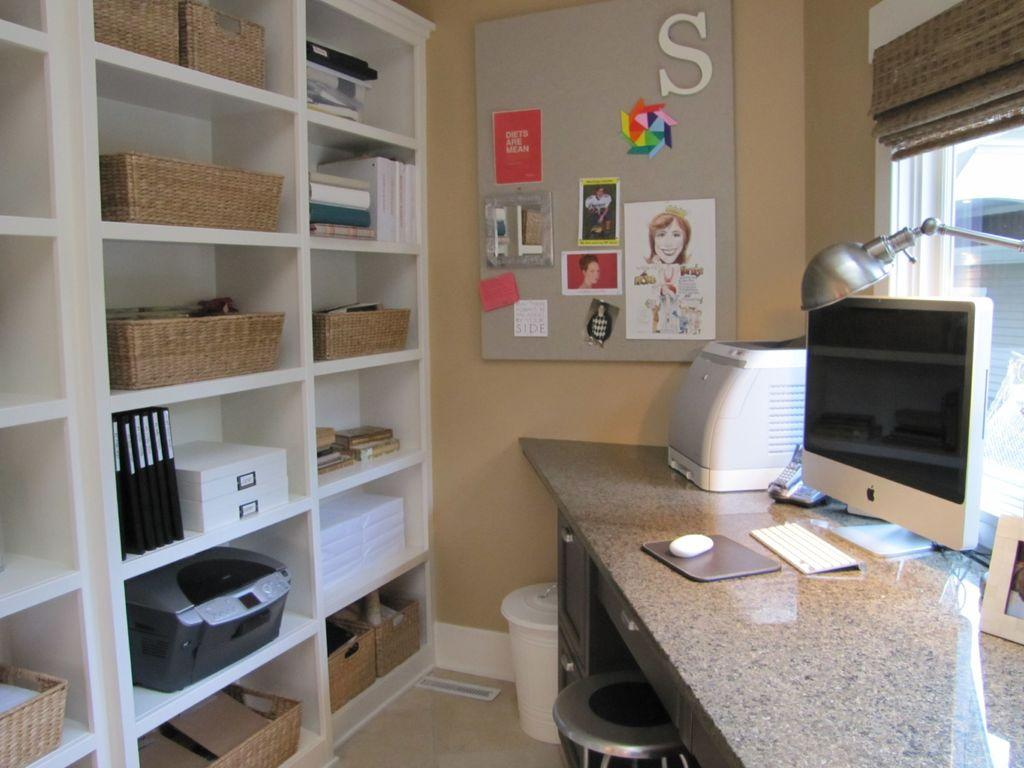<image>
Offer a succinct explanation of the picture presented. A white letter S is on the bulletin board along with some small cards. 